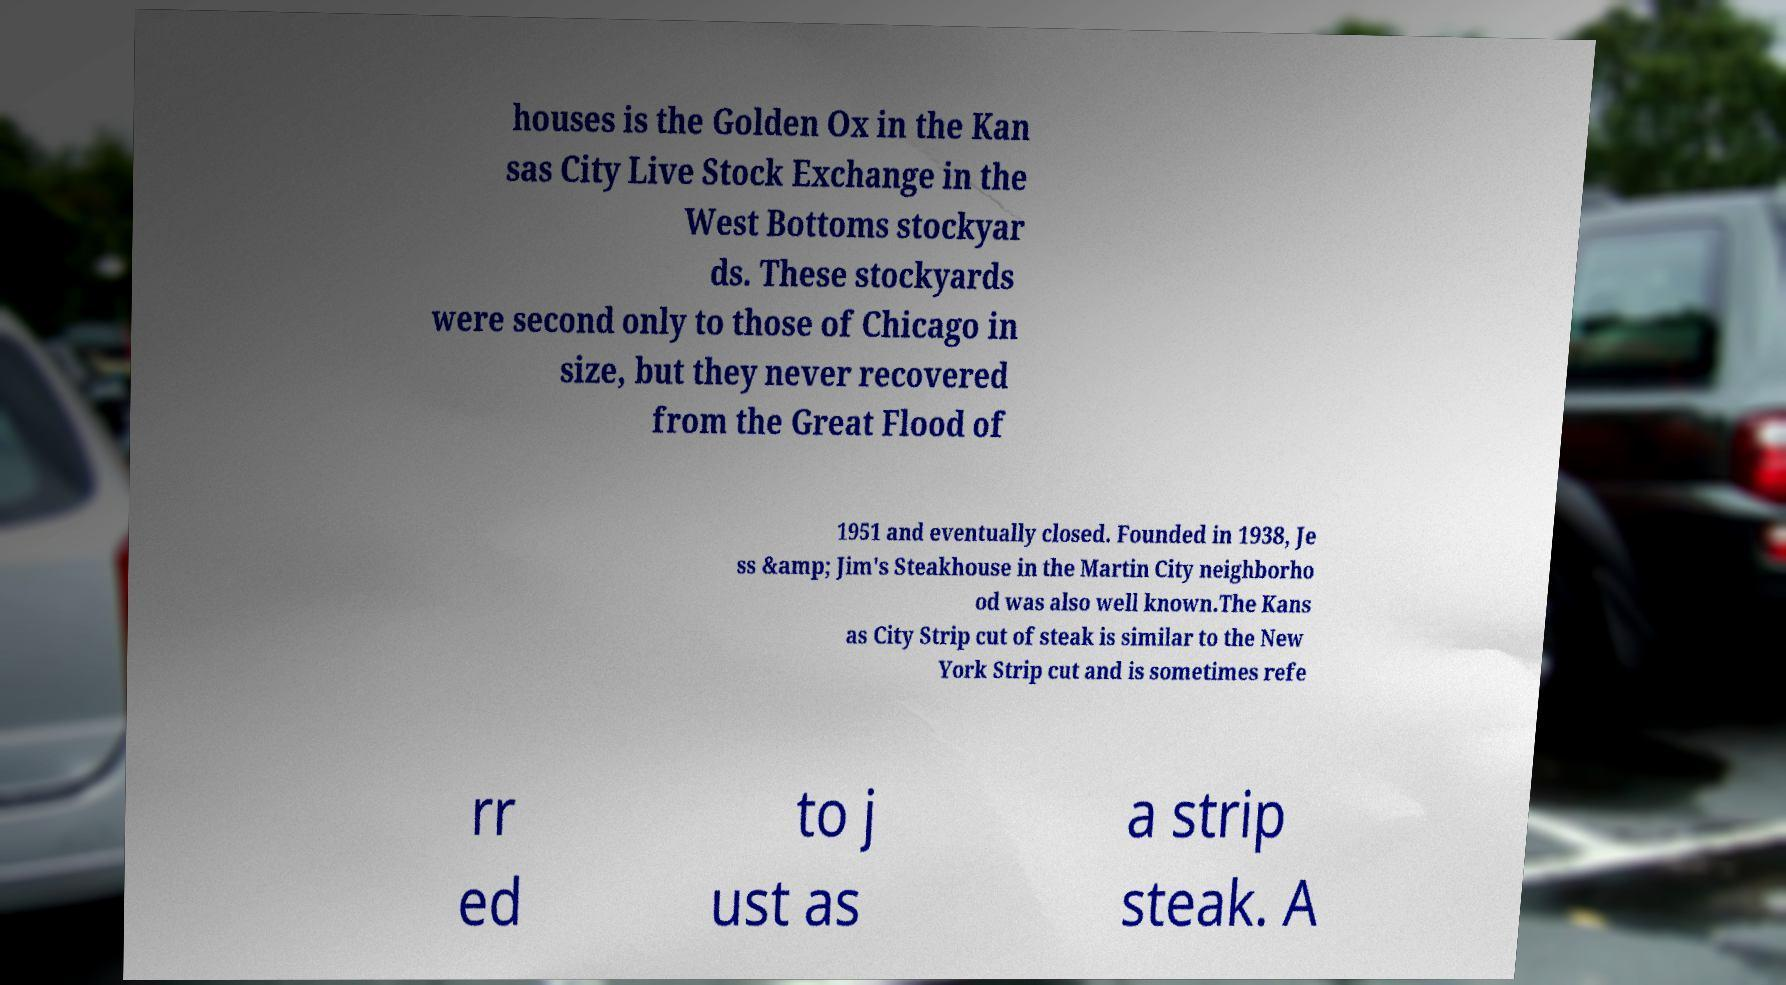Can you accurately transcribe the text from the provided image for me? houses is the Golden Ox in the Kan sas City Live Stock Exchange in the West Bottoms stockyar ds. These stockyards were second only to those of Chicago in size, but they never recovered from the Great Flood of 1951 and eventually closed. Founded in 1938, Je ss &amp; Jim's Steakhouse in the Martin City neighborho od was also well known.The Kans as City Strip cut of steak is similar to the New York Strip cut and is sometimes refe rr ed to j ust as a strip steak. A 